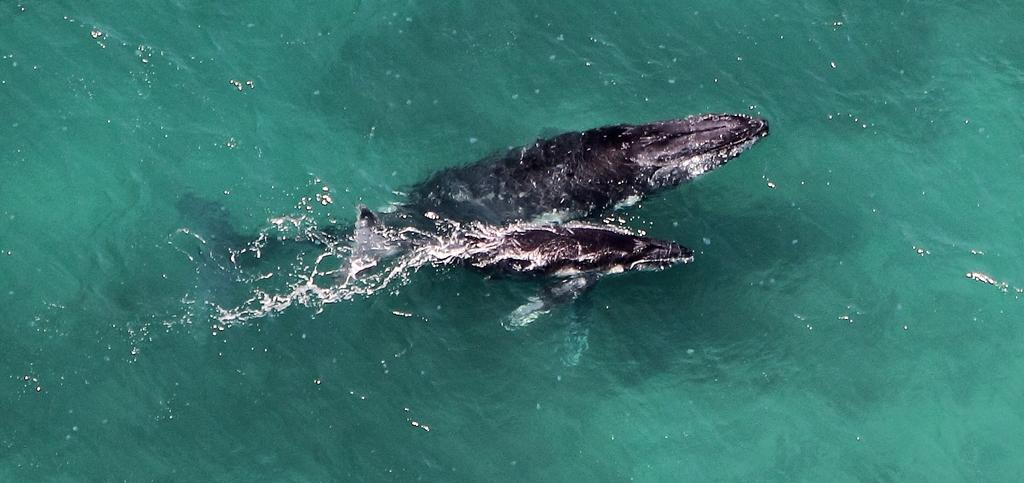What type of animals are in the image? There are gray whales in the image. Where are the whales located? The whales are in the water. What type of coat are the whales wearing in the image? Whales do not wear coats, so this detail cannot be found in the image. 